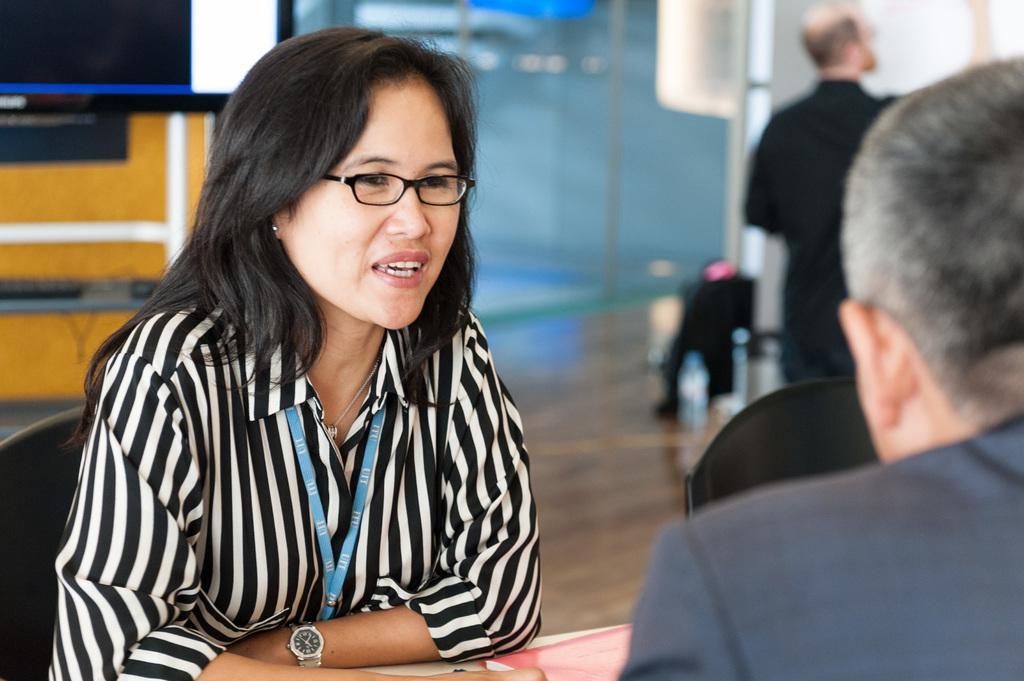Could you give a brief overview of what you see in this image? In the foreground of this image, on the right, there is a man. On the left, there is a woman sitting on the chair in front of a table on which, there is a book and there is another chair beside her. In the background, there is a man standing on the floor, glass wall, a screen, stand and the wall. 